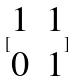<formula> <loc_0><loc_0><loc_500><loc_500>[ \begin{matrix} 1 & 1 \\ 0 & 1 \end{matrix} ]</formula> 